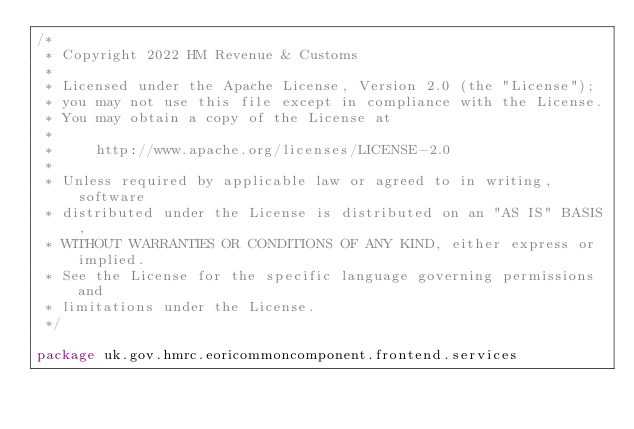Convert code to text. <code><loc_0><loc_0><loc_500><loc_500><_Scala_>/*
 * Copyright 2022 HM Revenue & Customs
 *
 * Licensed under the Apache License, Version 2.0 (the "License");
 * you may not use this file except in compliance with the License.
 * You may obtain a copy of the License at
 *
 *     http://www.apache.org/licenses/LICENSE-2.0
 *
 * Unless required by applicable law or agreed to in writing, software
 * distributed under the License is distributed on an "AS IS" BASIS,
 * WITHOUT WARRANTIES OR CONDITIONS OF ANY KIND, either express or implied.
 * See the License for the specific language governing permissions and
 * limitations under the License.
 */

package uk.gov.hmrc.eoricommoncomponent.frontend.services
</code> 